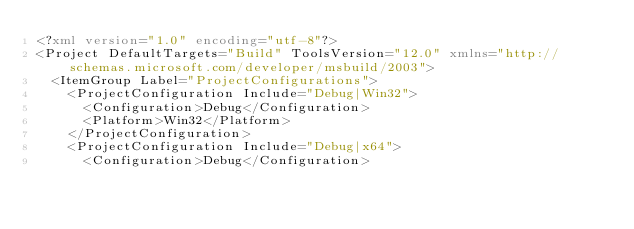<code> <loc_0><loc_0><loc_500><loc_500><_XML_><?xml version="1.0" encoding="utf-8"?>
<Project DefaultTargets="Build" ToolsVersion="12.0" xmlns="http://schemas.microsoft.com/developer/msbuild/2003">
  <ItemGroup Label="ProjectConfigurations">
    <ProjectConfiguration Include="Debug|Win32">
      <Configuration>Debug</Configuration>
      <Platform>Win32</Platform>
    </ProjectConfiguration>
    <ProjectConfiguration Include="Debug|x64">
      <Configuration>Debug</Configuration></code> 